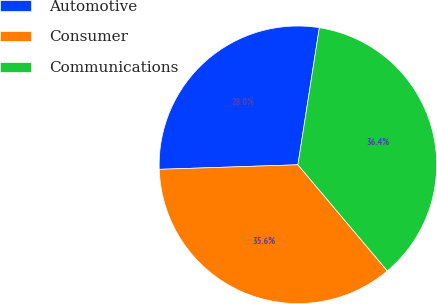Convert chart. <chart><loc_0><loc_0><loc_500><loc_500><pie_chart><fcel>Automotive<fcel>Consumer<fcel>Communications<nl><fcel>27.99%<fcel>35.62%<fcel>36.39%<nl></chart> 